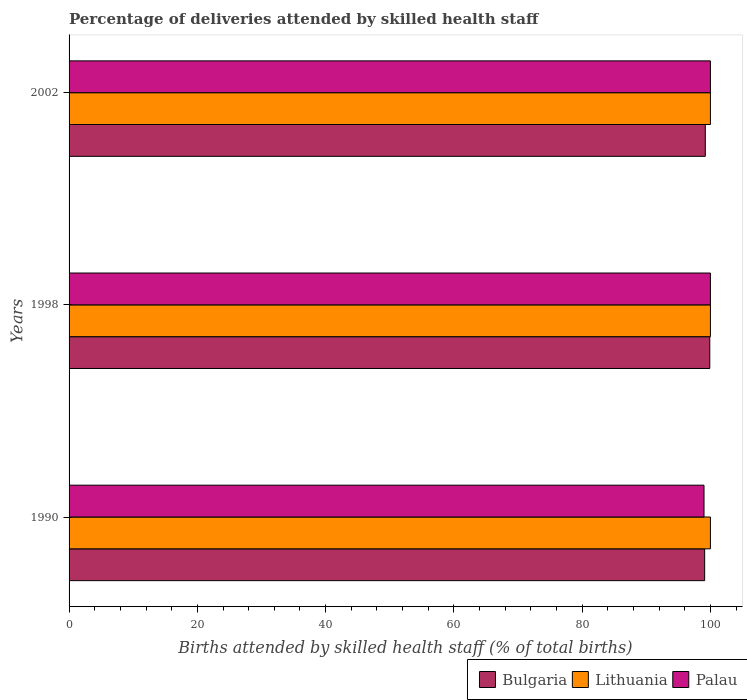How many groups of bars are there?
Ensure brevity in your answer.  3. How many bars are there on the 2nd tick from the top?
Offer a terse response. 3. What is the label of the 2nd group of bars from the top?
Provide a short and direct response. 1998. Across all years, what is the maximum percentage of births attended by skilled health staff in Palau?
Offer a terse response. 100. Across all years, what is the minimum percentage of births attended by skilled health staff in Bulgaria?
Offer a very short reply. 99.1. In which year was the percentage of births attended by skilled health staff in Lithuania maximum?
Give a very brief answer. 1990. In which year was the percentage of births attended by skilled health staff in Palau minimum?
Provide a short and direct response. 1990. What is the total percentage of births attended by skilled health staff in Palau in the graph?
Offer a terse response. 299. What is the difference between the percentage of births attended by skilled health staff in Bulgaria in 1990 and that in 1998?
Make the answer very short. -0.8. What is the difference between the percentage of births attended by skilled health staff in Lithuania in 1990 and the percentage of births attended by skilled health staff in Bulgaria in 1998?
Give a very brief answer. 0.1. In the year 1998, what is the difference between the percentage of births attended by skilled health staff in Bulgaria and percentage of births attended by skilled health staff in Palau?
Your response must be concise. -0.1. In how many years, is the percentage of births attended by skilled health staff in Palau greater than 52 %?
Ensure brevity in your answer.  3. What is the ratio of the percentage of births attended by skilled health staff in Bulgaria in 1990 to that in 2002?
Offer a terse response. 1. Is the percentage of births attended by skilled health staff in Bulgaria in 1990 less than that in 1998?
Give a very brief answer. Yes. What is the difference between the highest and the second highest percentage of births attended by skilled health staff in Lithuania?
Provide a short and direct response. 0. What is the difference between the highest and the lowest percentage of births attended by skilled health staff in Lithuania?
Provide a succinct answer. 0. How many bars are there?
Offer a very short reply. 9. Are the values on the major ticks of X-axis written in scientific E-notation?
Provide a succinct answer. No. Does the graph contain any zero values?
Offer a terse response. No. Does the graph contain grids?
Make the answer very short. No. How are the legend labels stacked?
Offer a very short reply. Horizontal. What is the title of the graph?
Provide a succinct answer. Percentage of deliveries attended by skilled health staff. Does "Palau" appear as one of the legend labels in the graph?
Offer a terse response. Yes. What is the label or title of the X-axis?
Offer a terse response. Births attended by skilled health staff (% of total births). What is the Births attended by skilled health staff (% of total births) of Bulgaria in 1990?
Make the answer very short. 99.1. What is the Births attended by skilled health staff (% of total births) in Bulgaria in 1998?
Ensure brevity in your answer.  99.9. What is the Births attended by skilled health staff (% of total births) in Palau in 1998?
Your answer should be very brief. 100. What is the Births attended by skilled health staff (% of total births) in Bulgaria in 2002?
Give a very brief answer. 99.2. What is the Births attended by skilled health staff (% of total births) of Lithuania in 2002?
Provide a succinct answer. 100. What is the Births attended by skilled health staff (% of total births) in Palau in 2002?
Give a very brief answer. 100. Across all years, what is the maximum Births attended by skilled health staff (% of total births) of Bulgaria?
Provide a succinct answer. 99.9. Across all years, what is the minimum Births attended by skilled health staff (% of total births) in Bulgaria?
Provide a succinct answer. 99.1. What is the total Births attended by skilled health staff (% of total births) of Bulgaria in the graph?
Your answer should be compact. 298.2. What is the total Births attended by skilled health staff (% of total births) in Lithuania in the graph?
Keep it short and to the point. 300. What is the total Births attended by skilled health staff (% of total births) in Palau in the graph?
Your answer should be compact. 299. What is the difference between the Births attended by skilled health staff (% of total births) of Bulgaria in 1990 and that in 1998?
Give a very brief answer. -0.8. What is the difference between the Births attended by skilled health staff (% of total births) in Lithuania in 1990 and that in 1998?
Keep it short and to the point. 0. What is the difference between the Births attended by skilled health staff (% of total births) of Palau in 1990 and that in 1998?
Ensure brevity in your answer.  -1. What is the difference between the Births attended by skilled health staff (% of total births) in Lithuania in 1990 and that in 2002?
Offer a terse response. 0. What is the difference between the Births attended by skilled health staff (% of total births) in Palau in 1998 and that in 2002?
Your response must be concise. 0. What is the difference between the Births attended by skilled health staff (% of total births) of Bulgaria in 1990 and the Births attended by skilled health staff (% of total births) of Lithuania in 1998?
Offer a terse response. -0.9. What is the difference between the Births attended by skilled health staff (% of total births) of Bulgaria in 1990 and the Births attended by skilled health staff (% of total births) of Palau in 2002?
Make the answer very short. -0.9. What is the difference between the Births attended by skilled health staff (% of total births) in Lithuania in 1990 and the Births attended by skilled health staff (% of total births) in Palau in 2002?
Your response must be concise. 0. What is the average Births attended by skilled health staff (% of total births) of Bulgaria per year?
Offer a terse response. 99.4. What is the average Births attended by skilled health staff (% of total births) of Lithuania per year?
Provide a succinct answer. 100. What is the average Births attended by skilled health staff (% of total births) of Palau per year?
Your answer should be compact. 99.67. In the year 1990, what is the difference between the Births attended by skilled health staff (% of total births) of Bulgaria and Births attended by skilled health staff (% of total births) of Palau?
Give a very brief answer. 0.1. In the year 1990, what is the difference between the Births attended by skilled health staff (% of total births) in Lithuania and Births attended by skilled health staff (% of total births) in Palau?
Your answer should be very brief. 1. In the year 1998, what is the difference between the Births attended by skilled health staff (% of total births) of Bulgaria and Births attended by skilled health staff (% of total births) of Lithuania?
Your response must be concise. -0.1. In the year 1998, what is the difference between the Births attended by skilled health staff (% of total births) in Lithuania and Births attended by skilled health staff (% of total births) in Palau?
Give a very brief answer. 0. In the year 2002, what is the difference between the Births attended by skilled health staff (% of total births) in Bulgaria and Births attended by skilled health staff (% of total births) in Palau?
Offer a very short reply. -0.8. In the year 2002, what is the difference between the Births attended by skilled health staff (% of total births) of Lithuania and Births attended by skilled health staff (% of total births) of Palau?
Your answer should be compact. 0. What is the ratio of the Births attended by skilled health staff (% of total births) in Bulgaria in 1998 to that in 2002?
Provide a short and direct response. 1.01. What is the difference between the highest and the second highest Births attended by skilled health staff (% of total births) of Palau?
Provide a short and direct response. 0. What is the difference between the highest and the lowest Births attended by skilled health staff (% of total births) in Bulgaria?
Give a very brief answer. 0.8. What is the difference between the highest and the lowest Births attended by skilled health staff (% of total births) in Palau?
Make the answer very short. 1. 